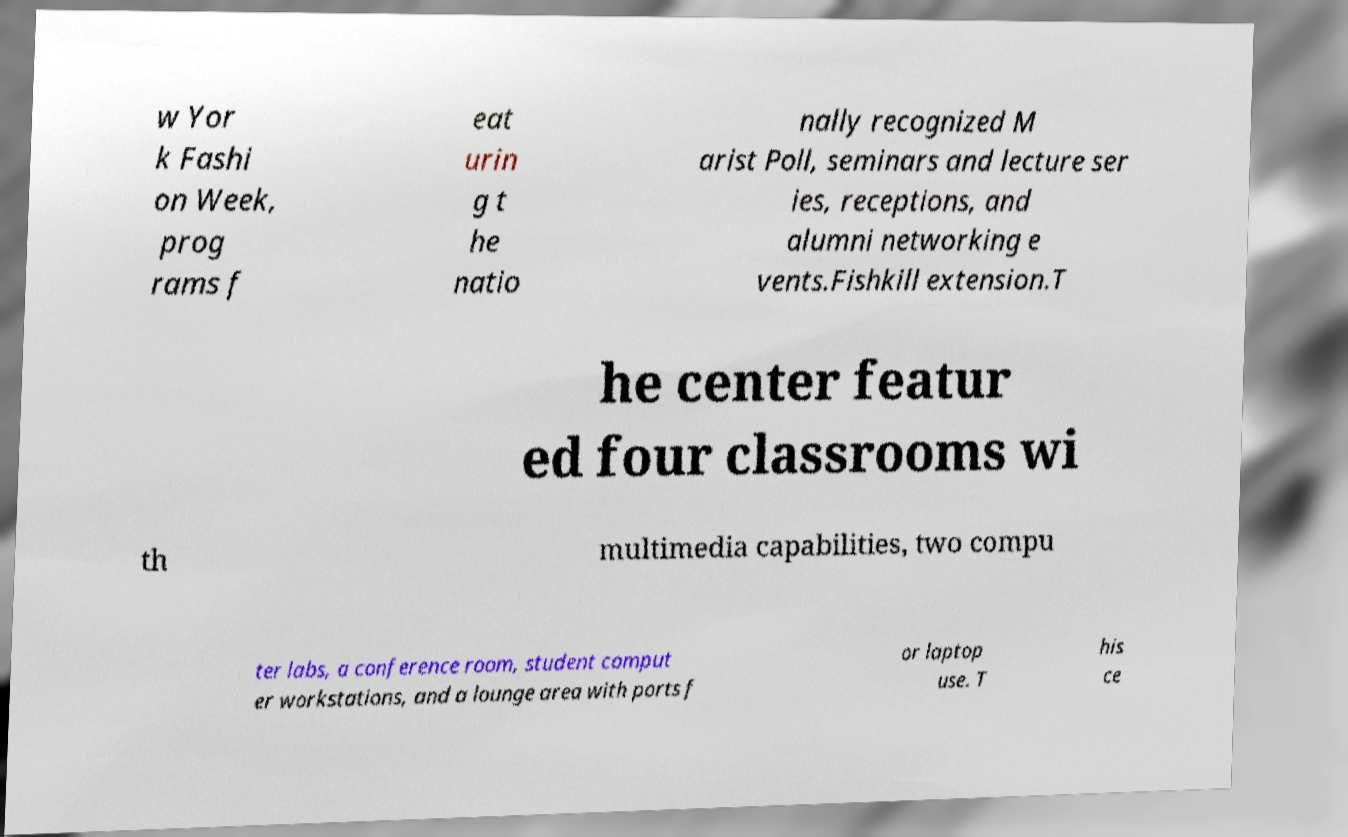For documentation purposes, I need the text within this image transcribed. Could you provide that? w Yor k Fashi on Week, prog rams f eat urin g t he natio nally recognized M arist Poll, seminars and lecture ser ies, receptions, and alumni networking e vents.Fishkill extension.T he center featur ed four classrooms wi th multimedia capabilities, two compu ter labs, a conference room, student comput er workstations, and a lounge area with ports f or laptop use. T his ce 